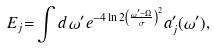Convert formula to latex. <formula><loc_0><loc_0><loc_500><loc_500>E _ { j } { = } \int d \, \omega ^ { \prime } e ^ { - 4 \ln 2 \left ( \frac { \omega ^ { \prime } - \Omega } { \sigma } \right ) ^ { 2 } } a _ { j } ^ { \prime } ( \omega ^ { \prime } ) ,</formula> 